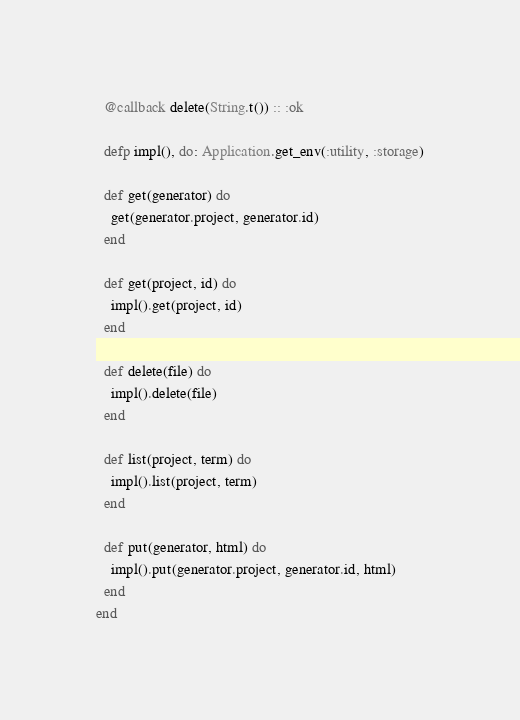Convert code to text. <code><loc_0><loc_0><loc_500><loc_500><_Elixir_>  @callback delete(String.t()) :: :ok

  defp impl(), do: Application.get_env(:utility, :storage)

  def get(generator) do
    get(generator.project, generator.id)
  end

  def get(project, id) do
    impl().get(project, id)
  end

  def delete(file) do
    impl().delete(file)
  end

  def list(project, term) do
    impl().list(project, term)
  end

  def put(generator, html) do
    impl().put(generator.project, generator.id, html)
  end
end
</code> 